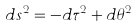<formula> <loc_0><loc_0><loc_500><loc_500>d s ^ { 2 } = - d \tau ^ { 2 } + d \theta ^ { 2 }</formula> 